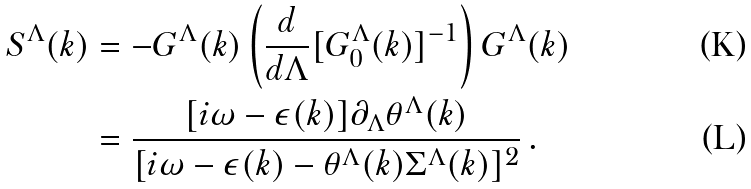Convert formula to latex. <formula><loc_0><loc_0><loc_500><loc_500>S ^ { \Lambda } ( k ) & = - G ^ { \Lambda } ( k ) \left ( \frac { d } { d \Lambda } [ G _ { 0 } ^ { \Lambda } ( k ) ] ^ { - 1 } \right ) G ^ { \Lambda } ( k ) \\ & = \frac { [ i \omega - \epsilon ( k ) ] \partial _ { \Lambda } \theta ^ { \Lambda } ( k ) } { [ i \omega - \epsilon ( k ) - \theta ^ { \Lambda } ( k ) \Sigma ^ { \Lambda } ( k ) ] ^ { 2 } } \, .</formula> 